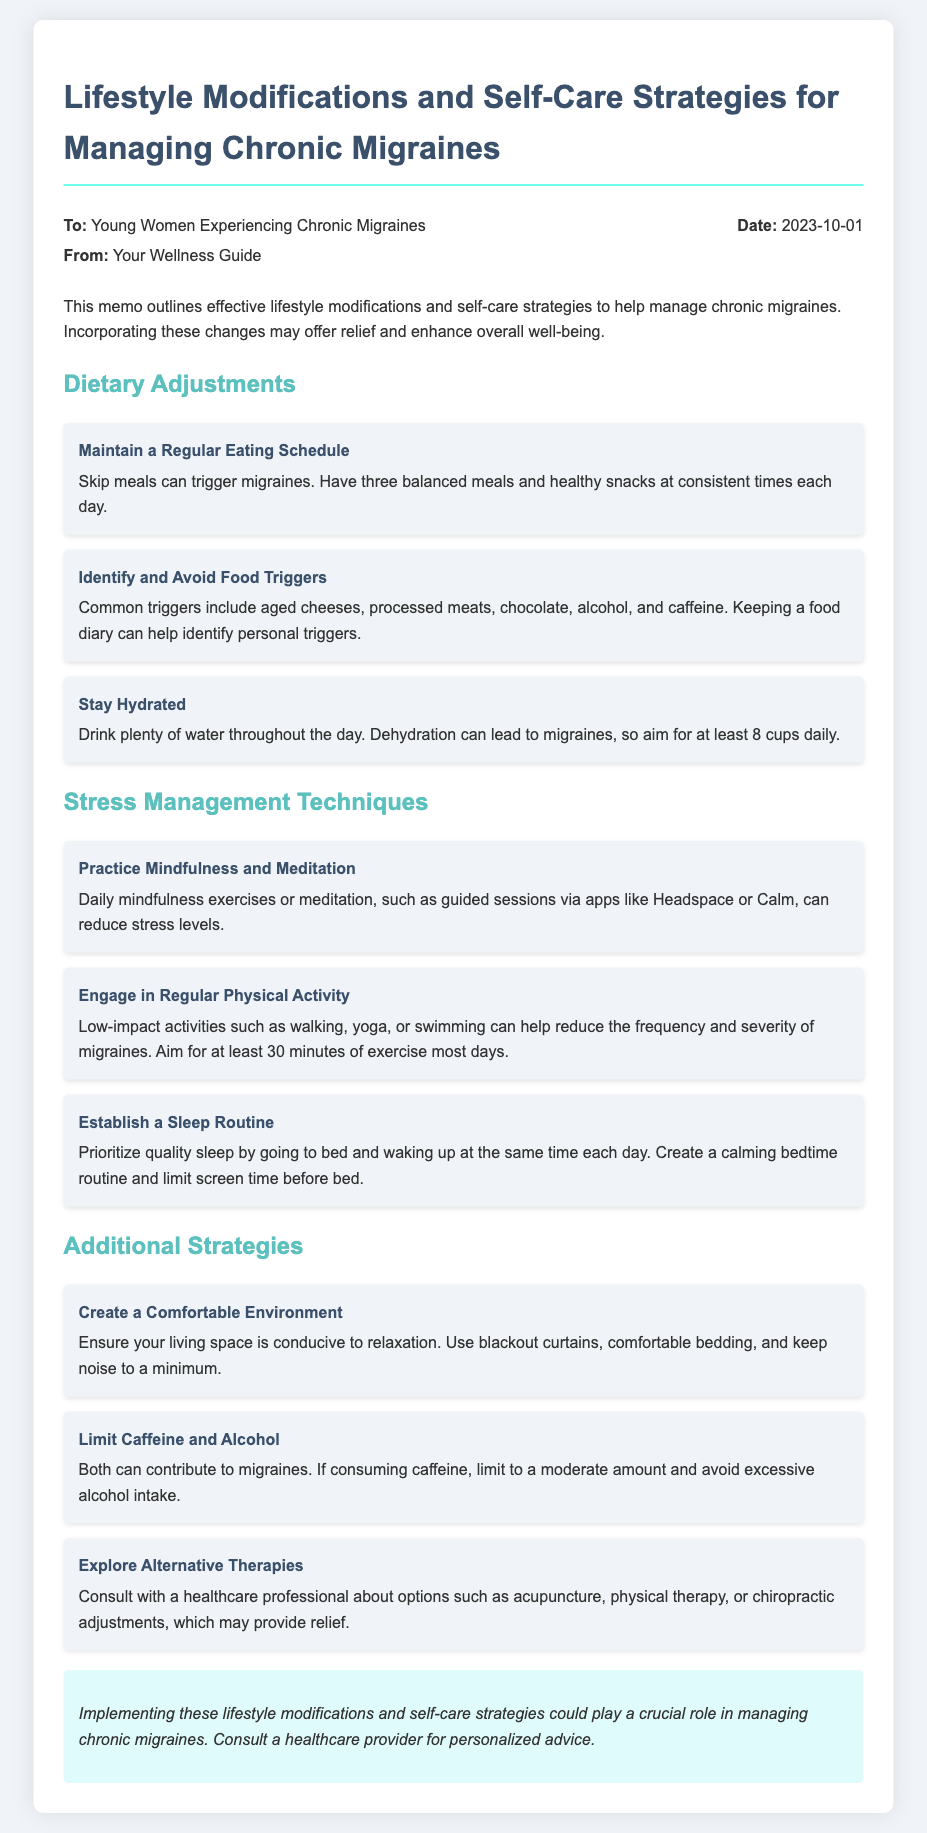What is the purpose of the memo? The memo outlines effective lifestyle modifications and self-care strategies to help manage chronic migraines.
Answer: To outline effective strategies for managing chronic migraines What are some common food triggers? The document lists aged cheeses, processed meats, chocolate, alcohol, and caffeine as common triggers.
Answer: Aged cheeses, processed meats, chocolate, alcohol, and caffeine How many cups of water should you drink daily? The recommendation in the memo is to aim for at least 8 cups daily to avoid dehydration.
Answer: At least 8 cups What is one technique suggested for stress management? The memo recommends practicing mindfulness and meditation to reduce stress levels.
Answer: Mindfulness and meditation What is a suggested type of physical activity? The document suggests engaging in low-impact activities like walking, yoga, or swimming.
Answer: Walking, yoga, or swimming How can you create a comfortable environment? The memo states to ensure your living space is conducive to relaxation, mentioning blackout curtains and comfortable bedding.
Answer: Blackout curtains and comfortable bedding What is advised regarding sleep? Establishing a sleep routine by going to bed and waking up at the same time each day is advised.
Answer: Establish a sleep routine Which alternative therapy might provide relief? The memo mentions consulting a healthcare professional about acupuncture as a possible alternative therapy.
Answer: Acupuncture When was the memo written? The date mentioned in the memo is October 1, 2023.
Answer: October 1, 2023 